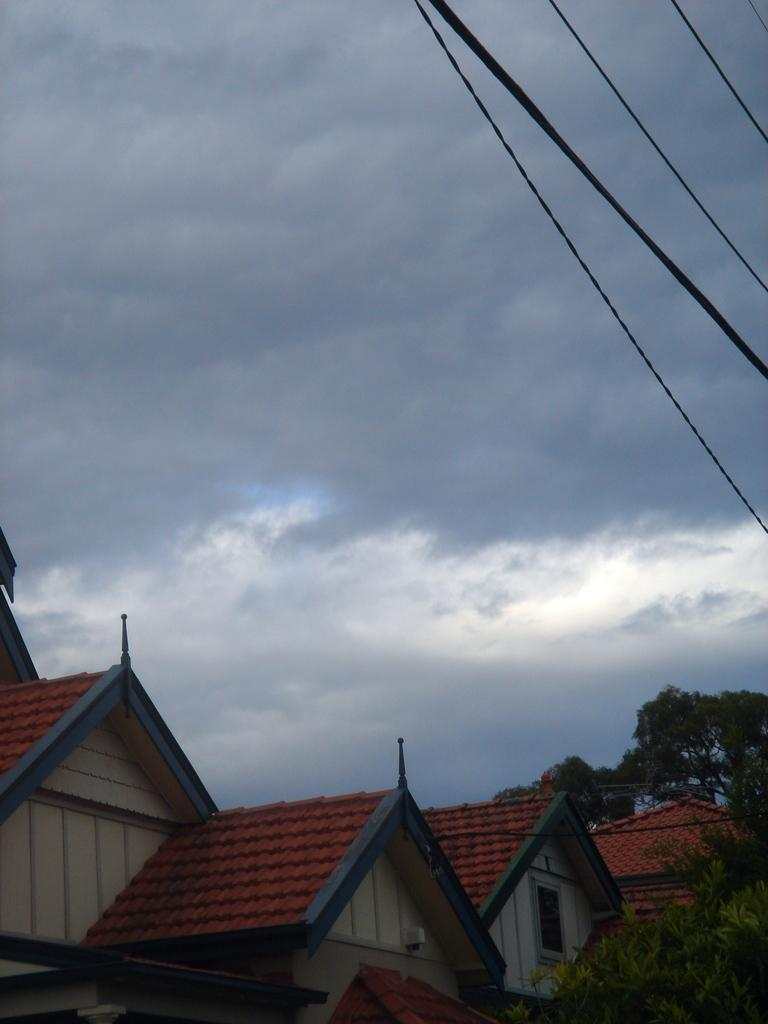What type of structures can be seen in the image? There are buildings in the image. What other natural elements are present in the image? There are trees and clouds in the image. What is visible at the top of the image? The sky is visible at the top of the image. What else can be seen in the image? There are wires and roof tiles on the top of the buildings. What is the size of the argument taking place in the image? There is no argument present in the image; it features buildings, trees, clouds, wires, and roof tiles. How much pain is the tree experiencing in the image? Trees do not experience pain, and there is no indication of any pain in the image. 